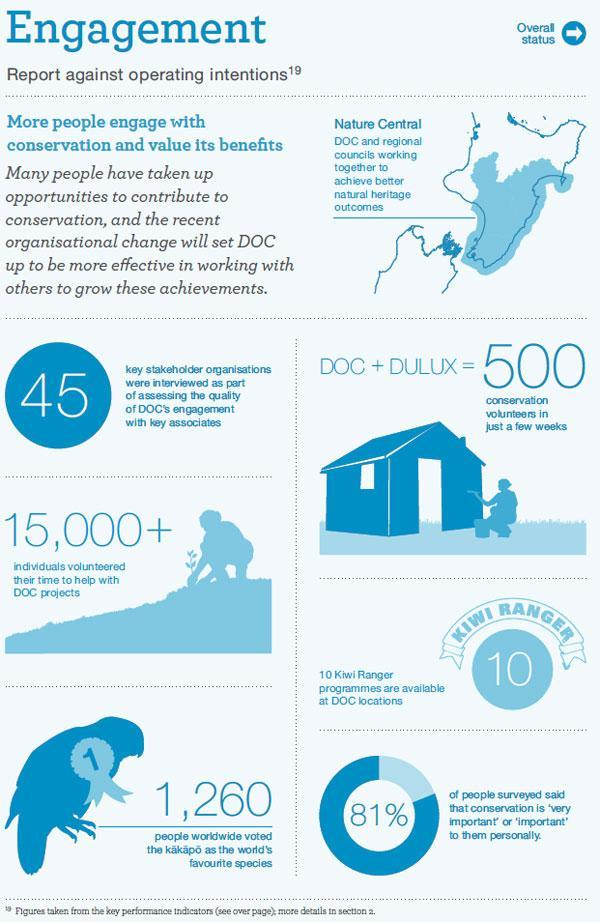How many people's icons are in this infographic?
Answer the question with a short phrase. 2 What is the number on the bird? 1 Conservation is not important to what percentage of people? 19% 